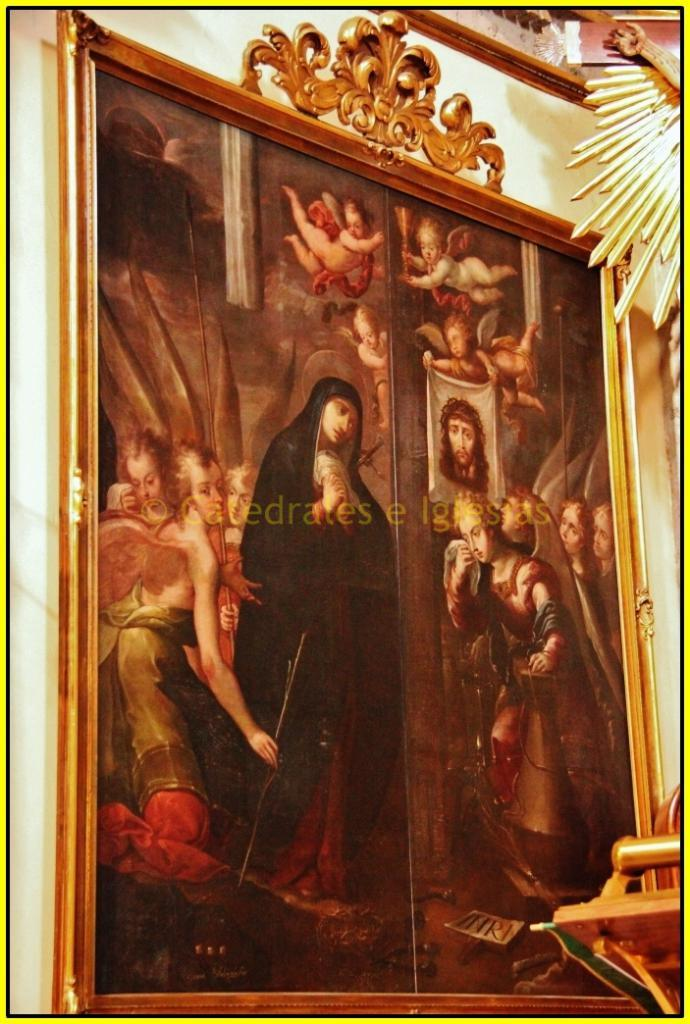What is hanging on the wall in the image? There is a frame on the wall in the image. What can be seen inside the frame? There are people visible in the frame. What type of arm is visible in the image? There is no arm visible in the image; only a frame with people inside is present. What game is being played in the middle of the image? There is no game being played in the image; it only features a frame with people inside. 